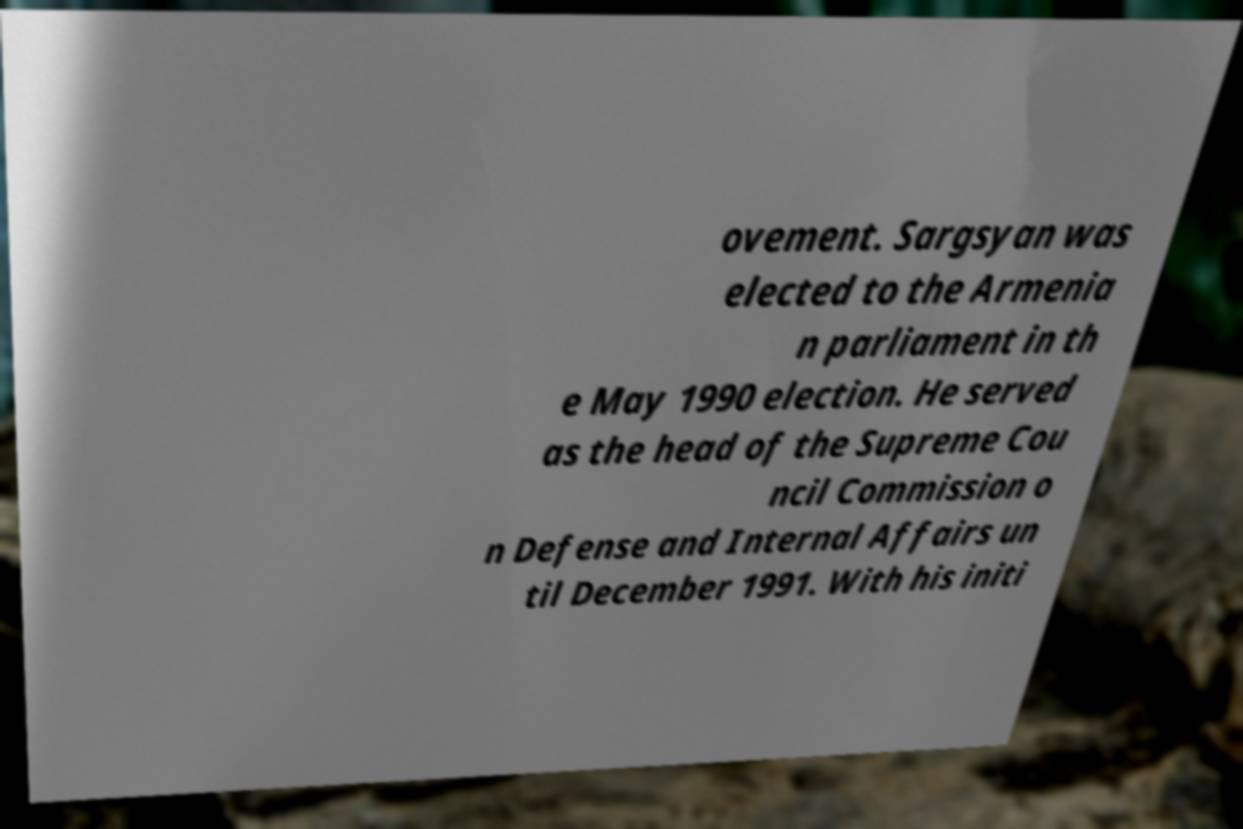Please identify and transcribe the text found in this image. ovement. Sargsyan was elected to the Armenia n parliament in th e May 1990 election. He served as the head of the Supreme Cou ncil Commission o n Defense and Internal Affairs un til December 1991. With his initi 